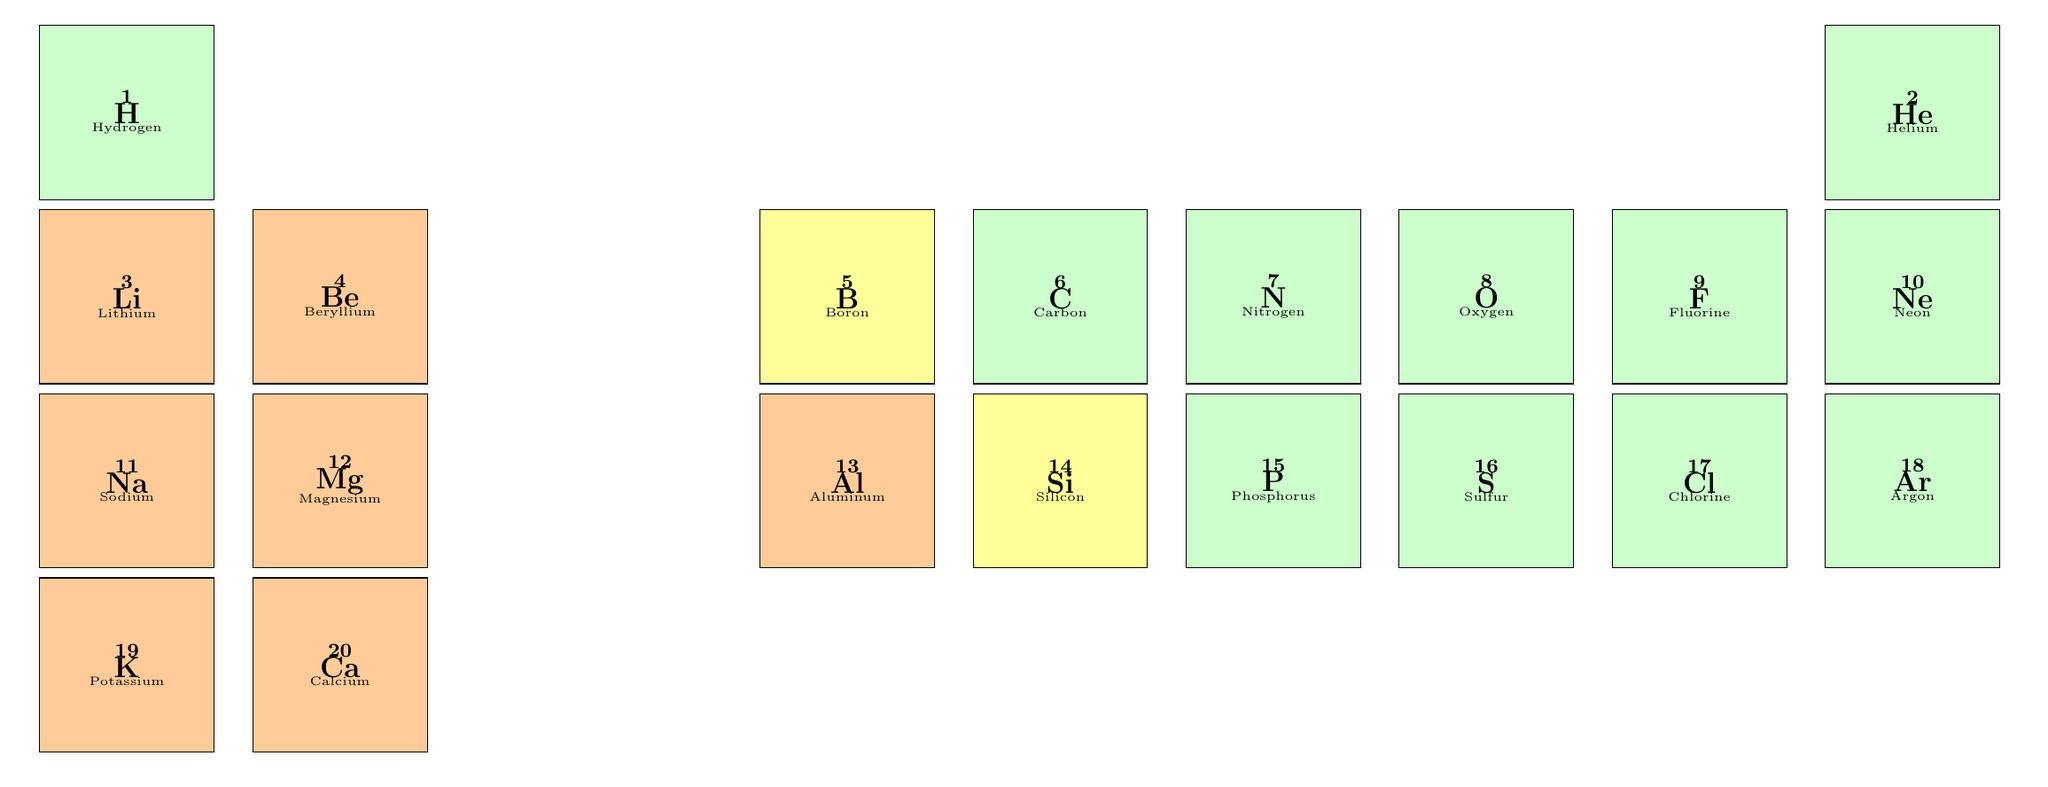What is the state of Nitrogen at room temperature? Referring to the table, Nitrogen is listed with its state at room temperature being "Gas."
Answer: Gas Which element has the highest electronegativity value? By examining the electronegativity values in the table, Fluorine has the highest value at 3.98.
Answer: Fluorine What is the atomic weight of Magnesium? The table states that Magnesium has an atomic weight of 24.305.
Answer: 24.305 How many Non-Metal elements are listed in the table? Counting the Non-Metal elements (Hydrogen, Helium, Carbon, Nitrogen, Oxygen, Fluorine, Neon, Phosphorus, Sulfur, Chlorine, Argon), we find there are 11 in total.
Answer: 11 Is Beryllium a Non-Metal? The table classifies Beryllium under the category "Metal," which means it is not a Non-Metal.
Answer: No What is the difference in melting points between Sodium and Aluminum? The melting point of Sodium is 97.79 and Aluminum is 660.32; the difference is 660.32 - 97.79 = 562.53.
Answer: 562.53 Which element has the lowest boiling point? The boiling points of all elements are examined, with Helium having the lowest boiling point at -268.93.
Answer: Helium If you average the atomic weights of Lithium, Sodium, and Potassium, what do you get? The atomic weights are Lithium: 6.94, Sodium: 22.990, and Potassium: 39.098. The average is (6.94 + 22.990 + 39.098) / 3 = 22.009.
Answer: 22.009 What is the melting point of Phosphorus? The table reveals that the melting point of Phosphorus is 44.15.
Answer: 44.15 